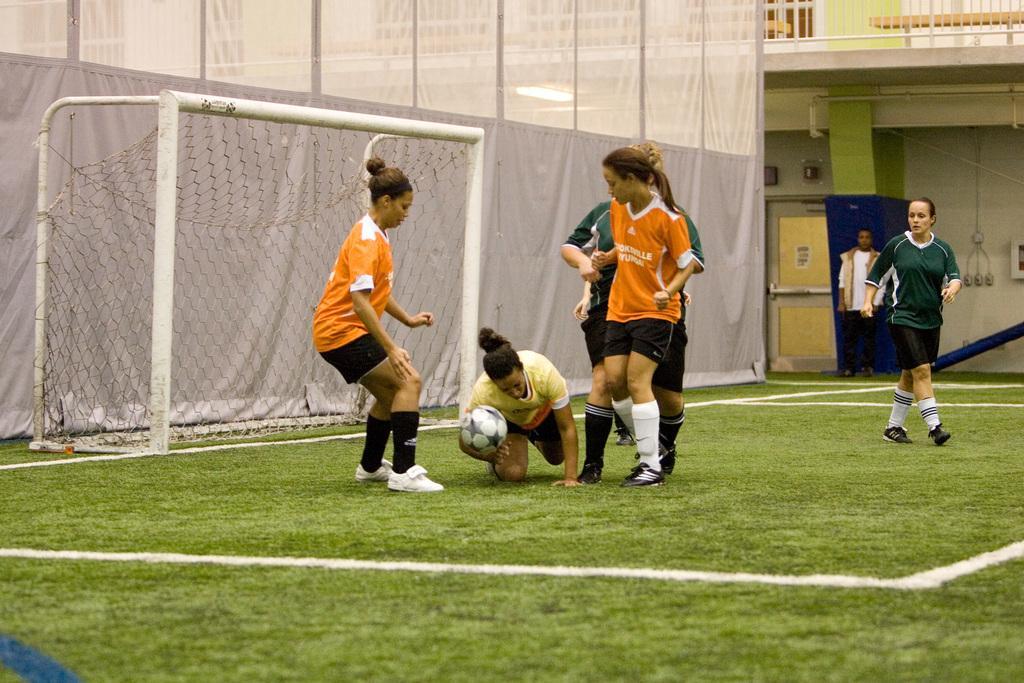In one or two sentences, can you explain what this image depicts? In this image I can see the group of people on the ground. Among them one person is holding the ball. In the background there is a net. 